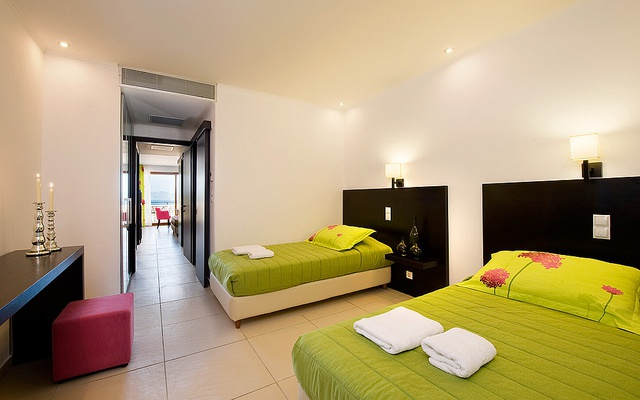Describe the objects in this image and their specific colors. I can see bed in tan, olive, gold, and lightgray tones, bed in tan, black, and olive tones, chair in tan, maroon, black, violet, and brown tones, vase in tan, black, olive, and gray tones, and chair in tan, brown, black, and lightpink tones in this image. 